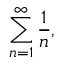Convert formula to latex. <formula><loc_0><loc_0><loc_500><loc_500>\sum _ { n = 1 } ^ { \infty } { \frac { 1 } { n } } ,</formula> 